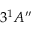<formula> <loc_0><loc_0><loc_500><loc_500>3 ^ { 1 } A ^ { \prime \prime }</formula> 